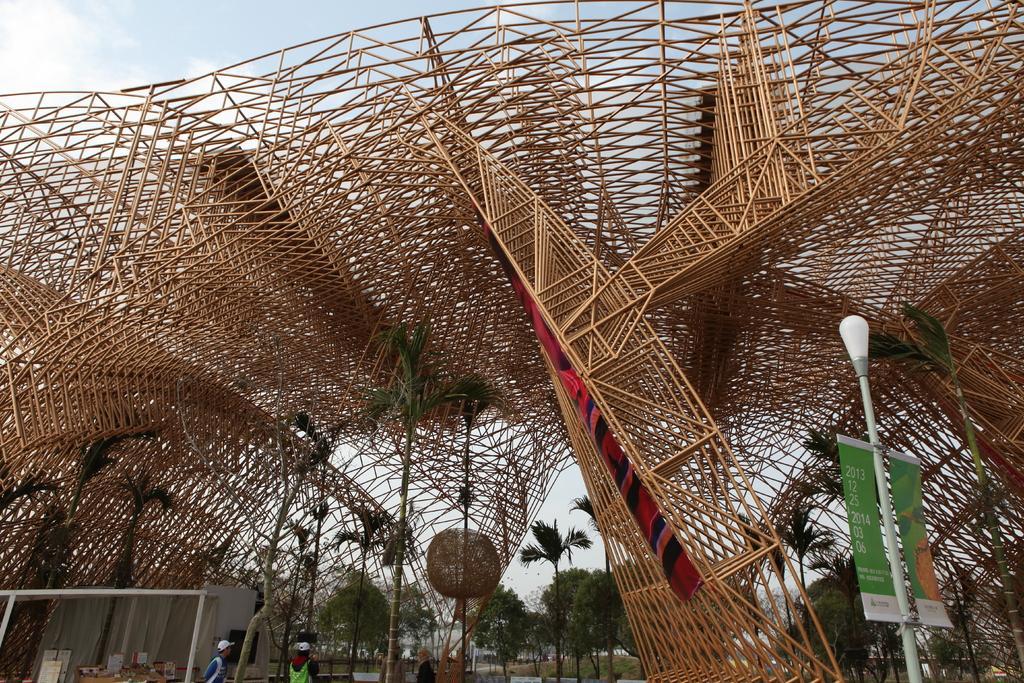In one or two sentences, can you explain what this image depicts? In this image I can see structure which is made up of metal rods which are in brown color. To the side I can see the light pole and the board to it. I can see two people with different color dresses. In the back there are many trees and the sky. To the left I can see the shed. 